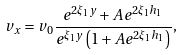Convert formula to latex. <formula><loc_0><loc_0><loc_500><loc_500>v _ { x } = v _ { 0 } \frac { e ^ { 2 \xi _ { 1 } y } + A e ^ { 2 \xi _ { 1 } h _ { 1 } } } { e ^ { \xi _ { 1 } y } \left ( 1 + A e ^ { 2 \xi _ { 1 } h _ { 1 } } \right ) } ,</formula> 